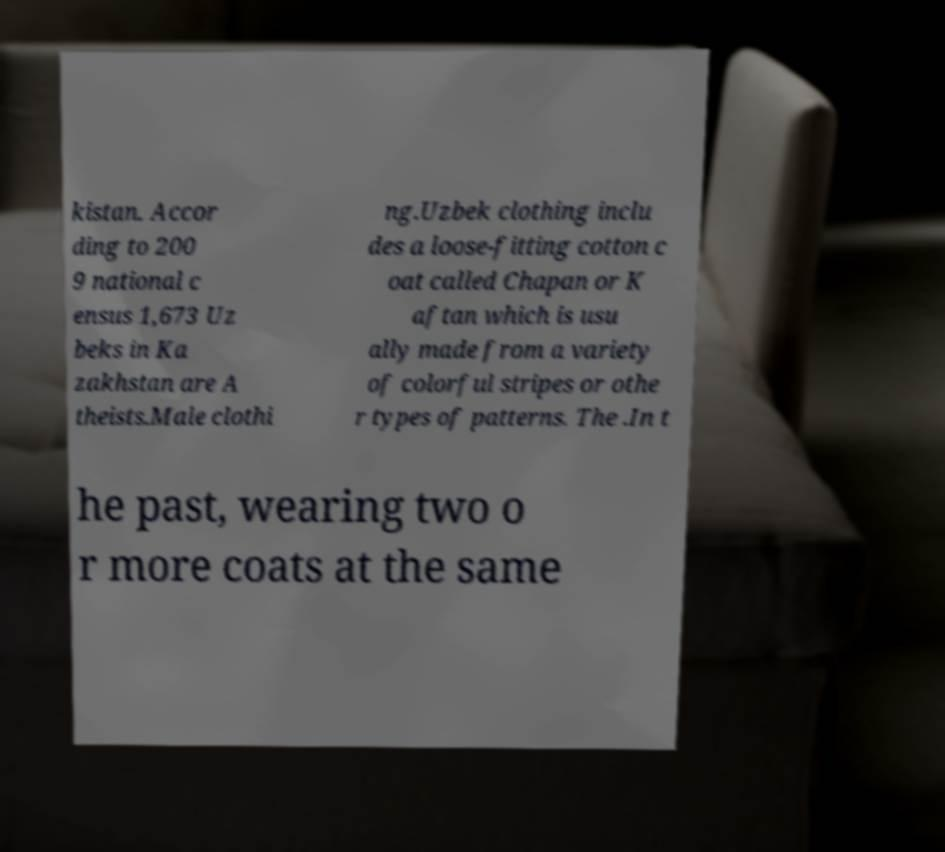For documentation purposes, I need the text within this image transcribed. Could you provide that? kistan. Accor ding to 200 9 national c ensus 1,673 Uz beks in Ka zakhstan are A theists.Male clothi ng.Uzbek clothing inclu des a loose-fitting cotton c oat called Chapan or K aftan which is usu ally made from a variety of colorful stripes or othe r types of patterns. The .In t he past, wearing two o r more coats at the same 